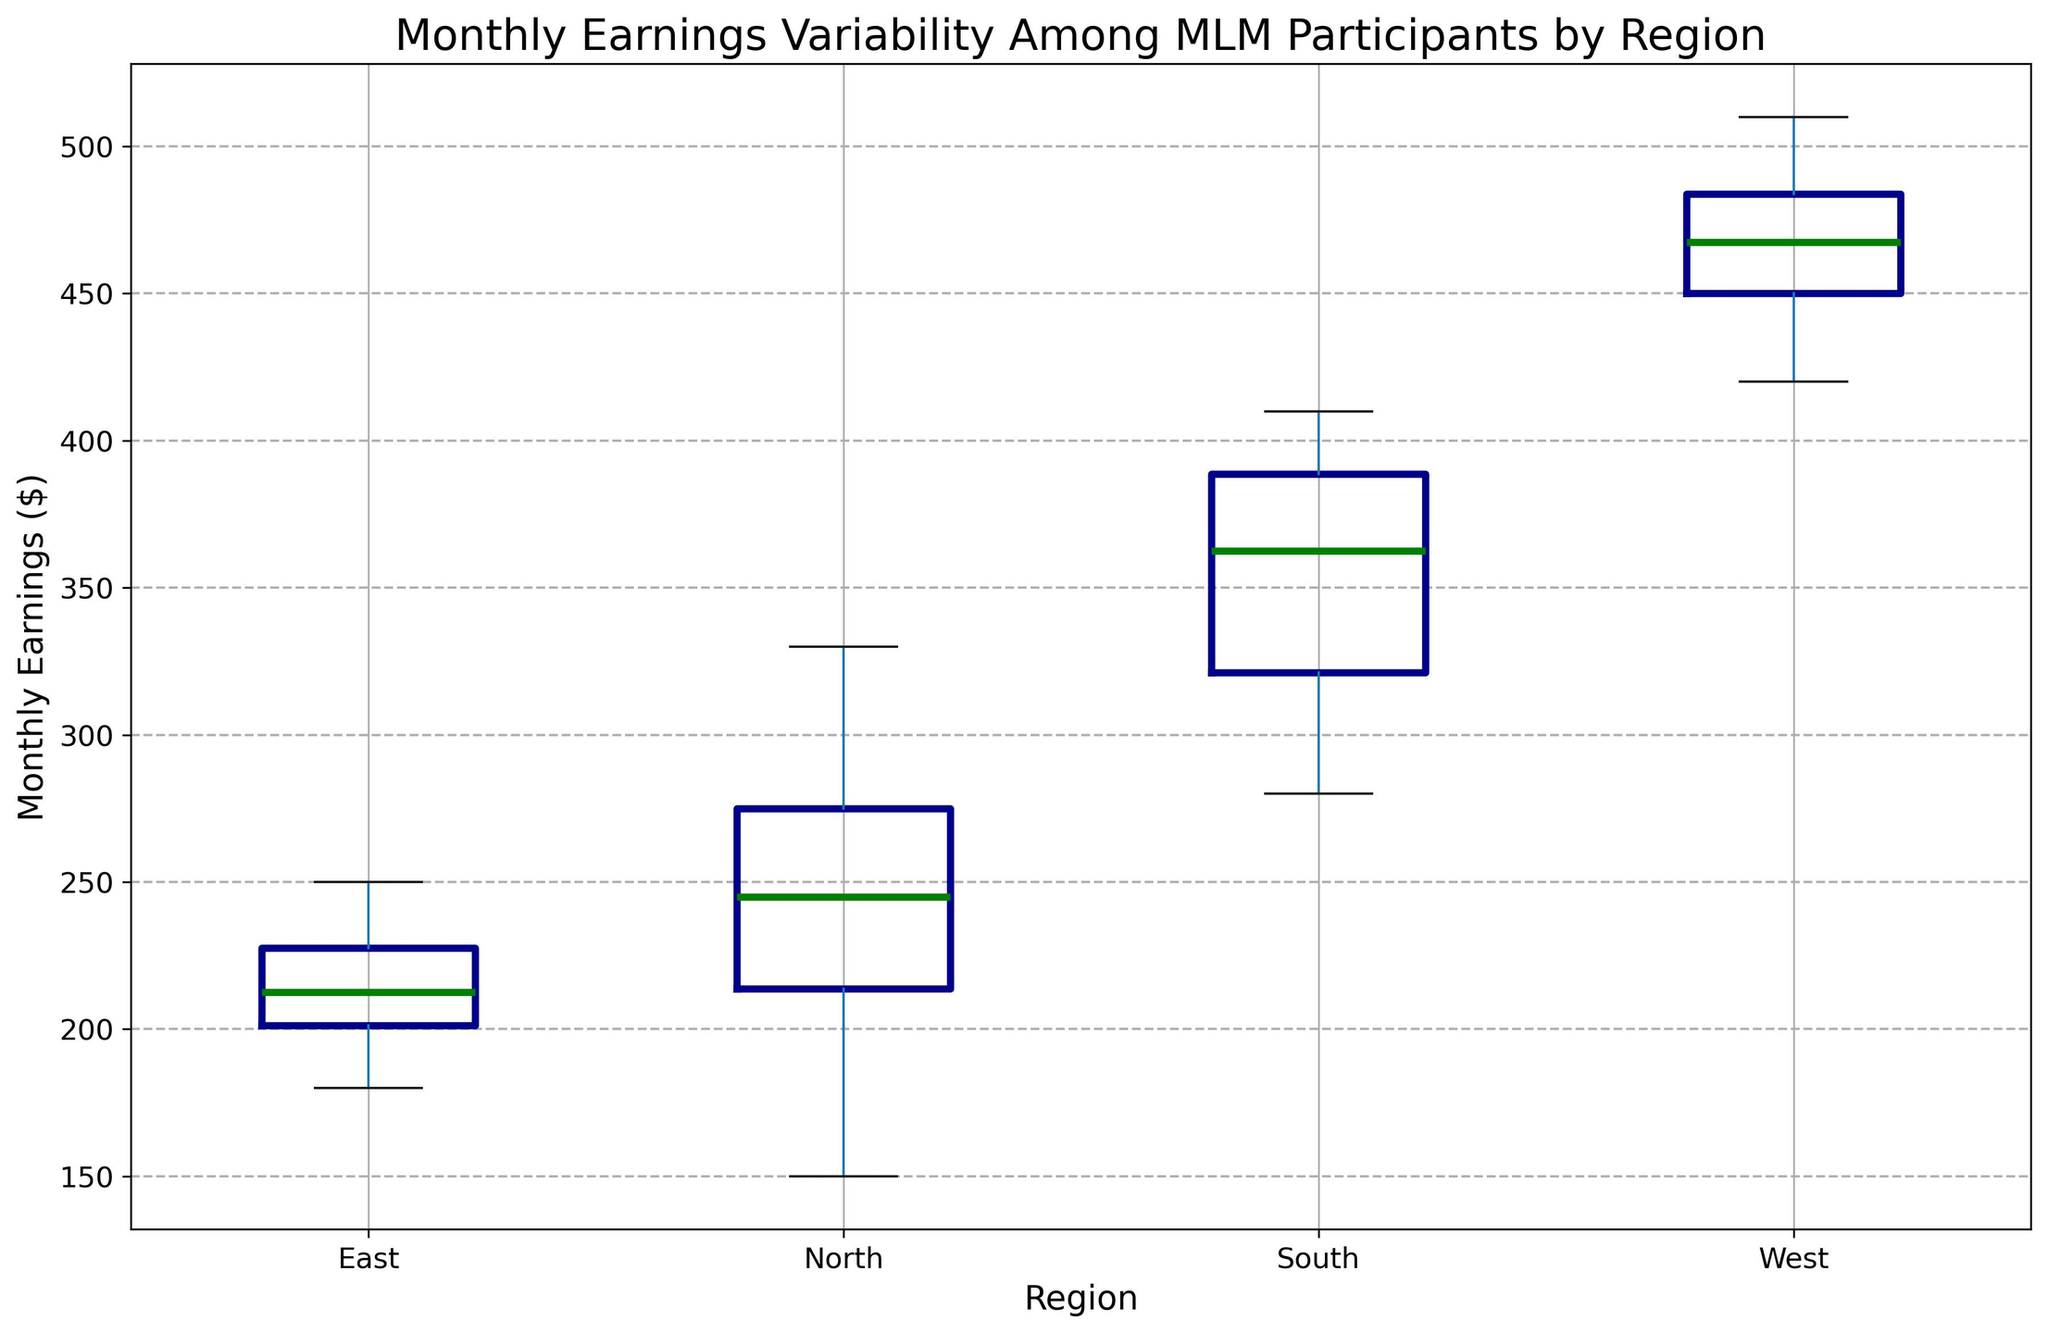What's the median monthly earnings in the West region? To find the median monthly earnings for the West region, look for the middle value in the sorted dataset for that region. The median is visually the horizontal line within the box for the West region.
Answer: 460 Which region has the highest variability in monthly earnings? The region with the highest variability is represented by the tallest box and widest range between the whiskers on the box plot. Identifying this indicates which region has the broadest spread in earnings.
Answer: West Compare the median monthly earnings between the North and South regions. Which is higher? To compare the median values, look at the horizontal lines inside the boxes for the North and South regions. The line for the South region is higher than for the North region.
Answer: South What is the interquartile range (IQR) for monthly earnings in the East region? The IQR is the range between the first quartile (bottom edge of the box) and the third quartile (top edge of the box) for the East region. The IQR is the height of the box.
Answer: 40 Which region has the smallest range of monthly earnings? The smallest range is indicated by the shortest distance between the top and bottom whiskers. Find the smallest vertical span across the whiskers.
Answer: East What's the difference between the maximum monthly earnings in the North and South regions? To find this, identify the top whiskers for the North and South regions, representing the maximum values, and subtract the North's maximum from the South's maximum.
Answer: 260 Which regions have outliers in their monthly earnings? Outliers are represented by points outside the whiskers in the box plot. Identify which regions have individual points marked outside the main range.
Answer: North, West How does the median monthly earnings of the East compare with the 75th percentile of the North? The 75th percentile is the top edge of the box for the North region. Compare this value with the horizontal line inside the box for the East region.
Answer: East is lower Examine the spread of monthly earnings for the South region. Does it appear to be evenly distributed, or skewed, based on the box plot? Look at the position of the median and the lengths of the upper and lower whiskers in the South region. If the median is centered and whiskers are of roughly equal length, it's evenly distributed. If not, it’s skewed.
Answer: Evenly distributed What's the lowest monthly earnings observed in the West region and how does it compare to the highest earnings in the North region? Identify the lowest point in the West and highest point in the North from the box plot whiskers and subtract the North's maximum from the West's minimum.
Answer: 90 